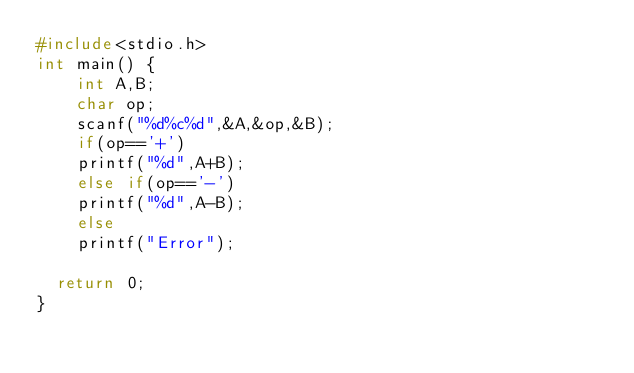Convert code to text. <code><loc_0><loc_0><loc_500><loc_500><_C_>#include<stdio.h>
int main() {
	  int A,B;
	  char op;
	  scanf("%d%c%d",&A,&op,&B);
	  if(op=='+')
		printf("%d",A+B);
	  else if(op=='-')
		printf("%d",A-B);
	  else
		printf("Error");

	return 0;
}



</code> 